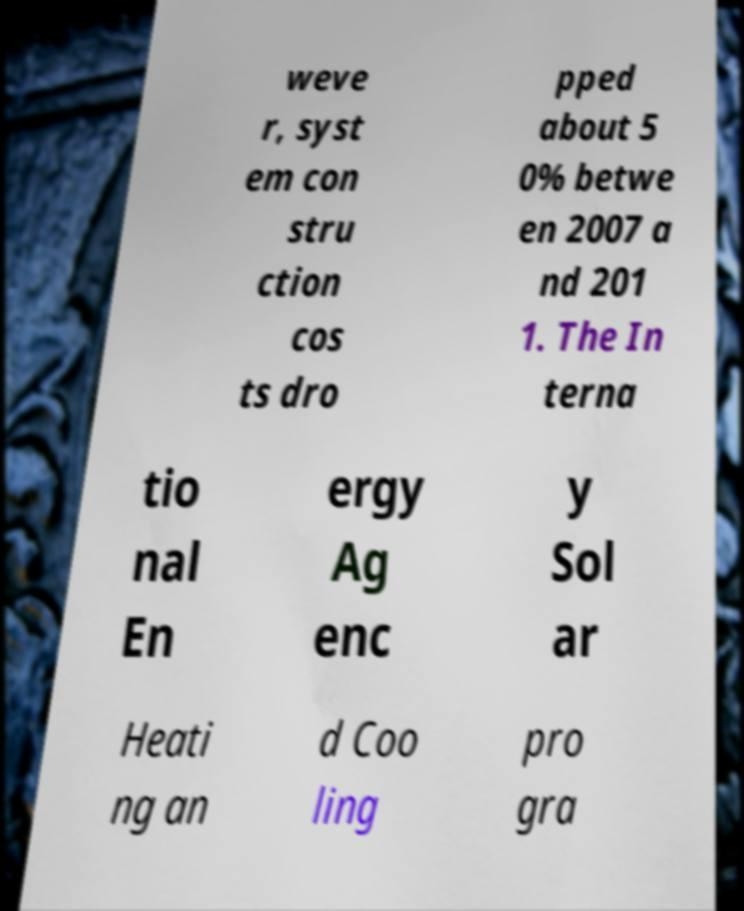I need the written content from this picture converted into text. Can you do that? weve r, syst em con stru ction cos ts dro pped about 5 0% betwe en 2007 a nd 201 1. The In terna tio nal En ergy Ag enc y Sol ar Heati ng an d Coo ling pro gra 